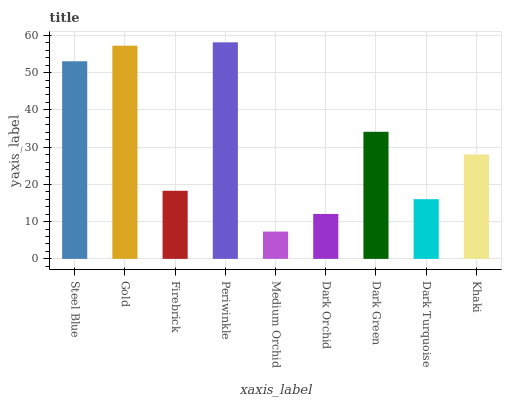Is Gold the minimum?
Answer yes or no. No. Is Gold the maximum?
Answer yes or no. No. Is Gold greater than Steel Blue?
Answer yes or no. Yes. Is Steel Blue less than Gold?
Answer yes or no. Yes. Is Steel Blue greater than Gold?
Answer yes or no. No. Is Gold less than Steel Blue?
Answer yes or no. No. Is Khaki the high median?
Answer yes or no. Yes. Is Khaki the low median?
Answer yes or no. Yes. Is Dark Green the high median?
Answer yes or no. No. Is Medium Orchid the low median?
Answer yes or no. No. 